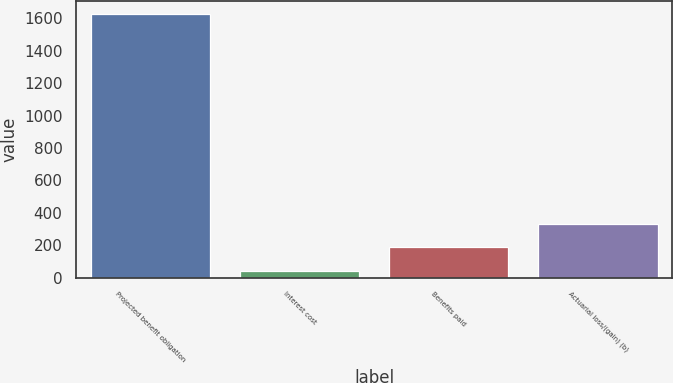<chart> <loc_0><loc_0><loc_500><loc_500><bar_chart><fcel>Projected benefit obligation<fcel>Interest cost<fcel>Benefits paid<fcel>Actuarial loss/(gain) (b)<nl><fcel>1624.2<fcel>42<fcel>186.2<fcel>330.4<nl></chart> 